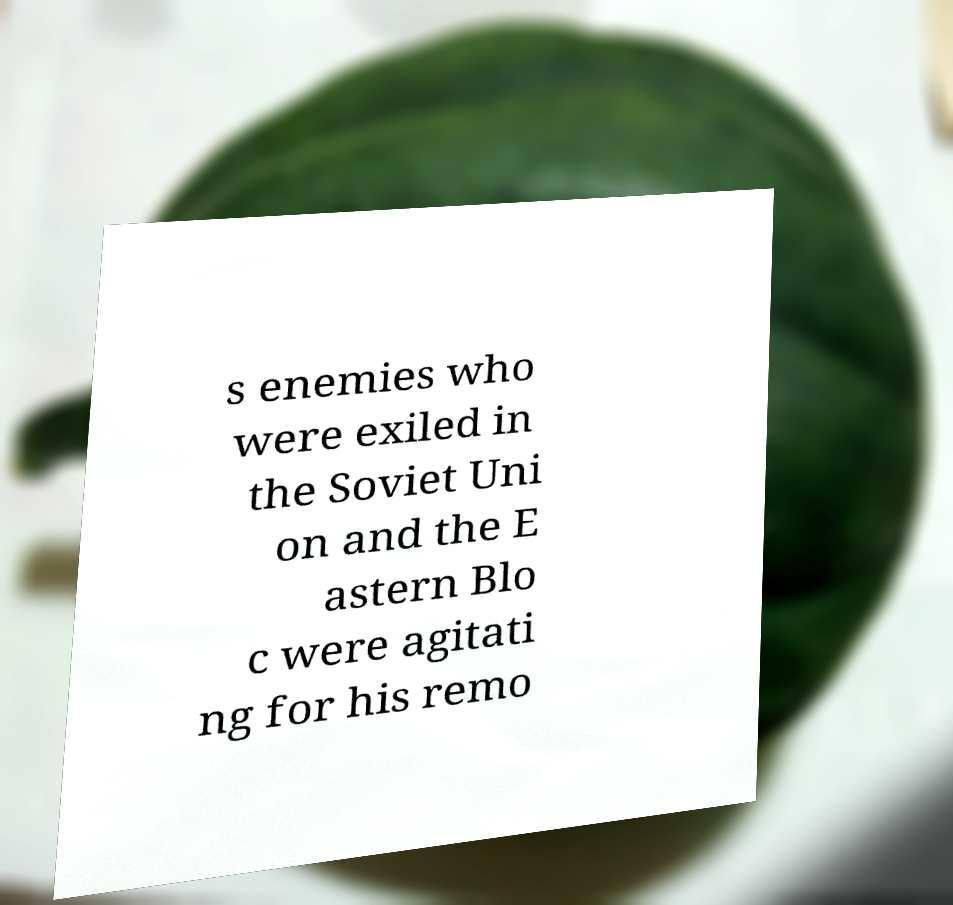For documentation purposes, I need the text within this image transcribed. Could you provide that? s enemies who were exiled in the Soviet Uni on and the E astern Blo c were agitati ng for his remo 